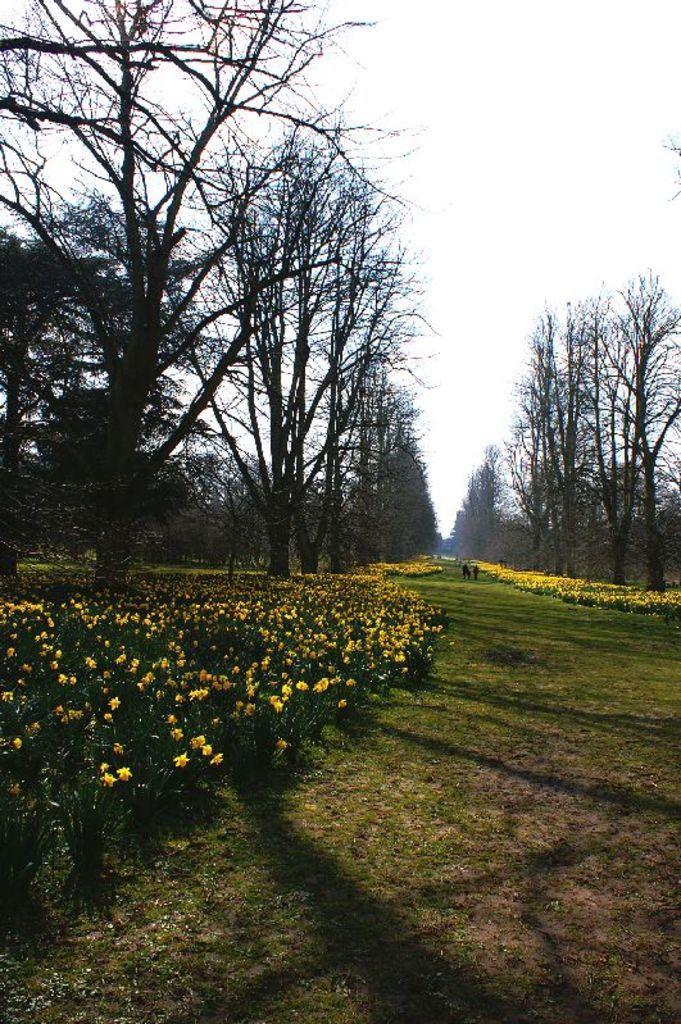Can you describe this image briefly? Here we can see plants, flowers, grass, and trees. In the background there is sky. 